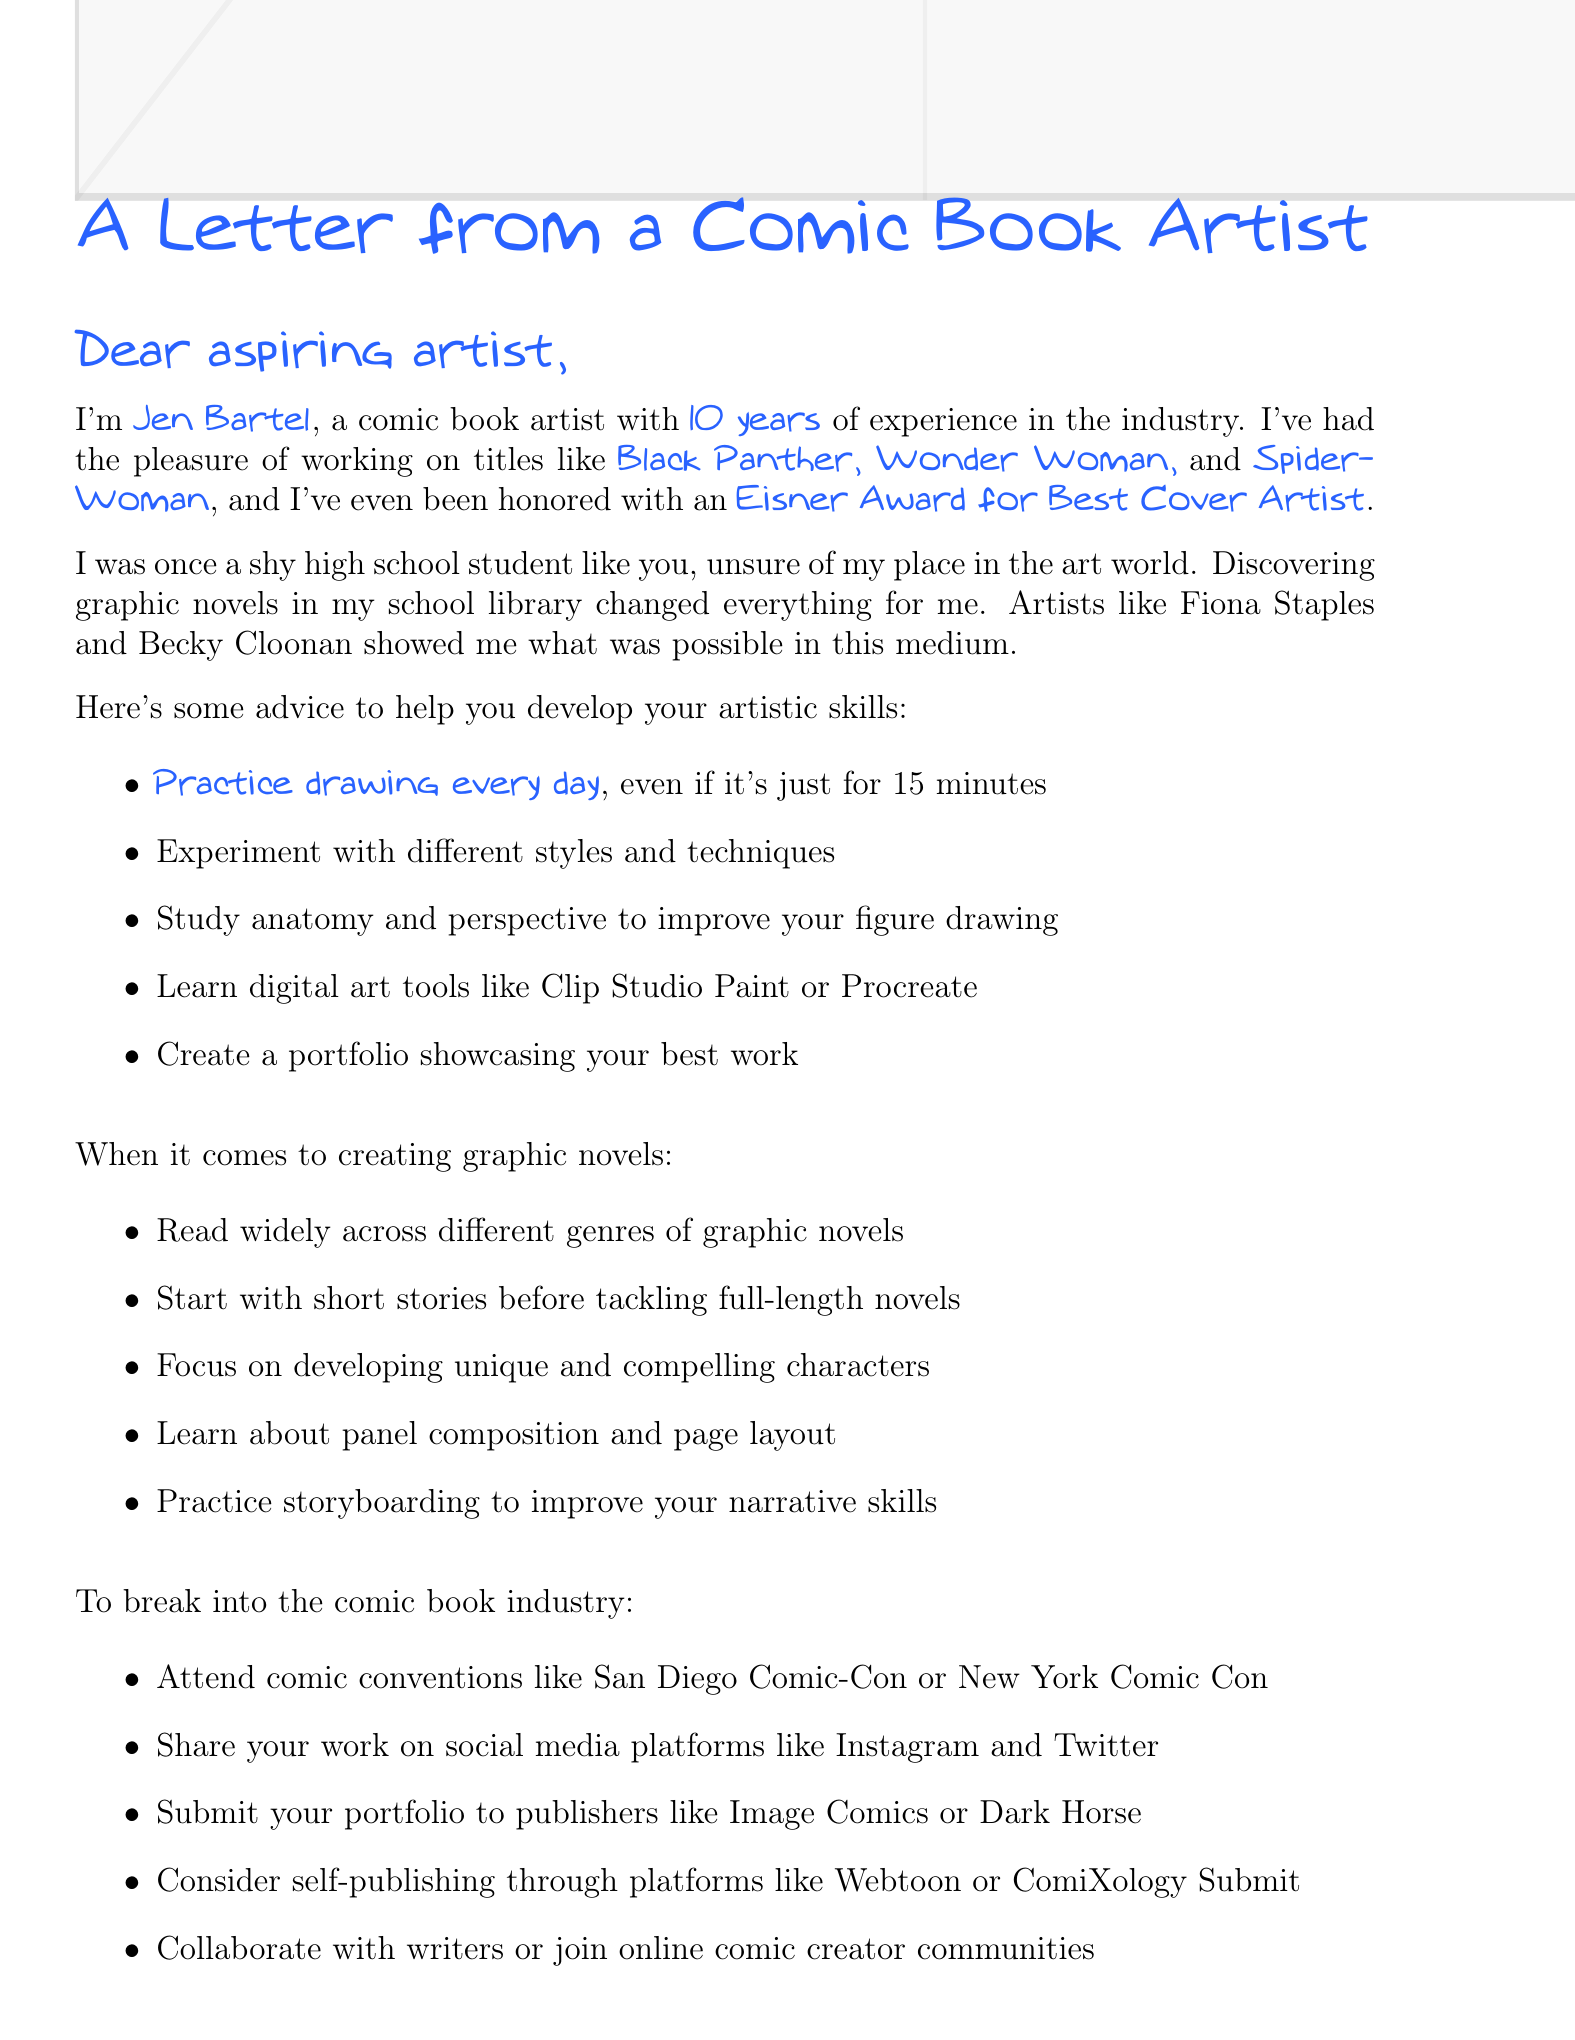What is the name of the comic book artist offering mentorship? The name of the artist is mentioned directly in the introduction of the letter.
Answer: Jen Bartel How many years of experience does Jen Bartel have? The letter states the number of years of experience in the introduction.
Answer: 10 years What notable works has Jen Bartel contributed to? The letter lists specific titles that Jen Bartel has worked on.
Answer: Black Panther, Wonder Woman, Spider-Woman What award has Jen Bartel received? This information is provided in the introduction of the letter, highlighting recognition in the industry.
Answer: Eisner Award for Best Cover Artist What is one tip for breaking into the comic book industry? The letter includes a list of tips for entering the industry, mentioning various actions an artist can take.
Answer: Attend comic conventions How did Jen Bartel's background influence her artistic journey? The letter reflects on her experience as a shy artist, illustrating her relatability and the turning point of discovering graphic novels.
Answer: She was once a shy high school student What is one piece of advice given for developing artistic skills? The letter lists specific advice that helps in enhancing artistic abilities.
Answer: Practice drawing every day Which resource is suggested for learning comic theory? The letter includes recommendations for resources that support learning about comics.
Answer: Scott McCloud's 'Understanding Comics' What type of document is this? The letter's structure and purpose indicate its type specifically aimed at providing mentorship and advice.
Answer: A mentorship letter 